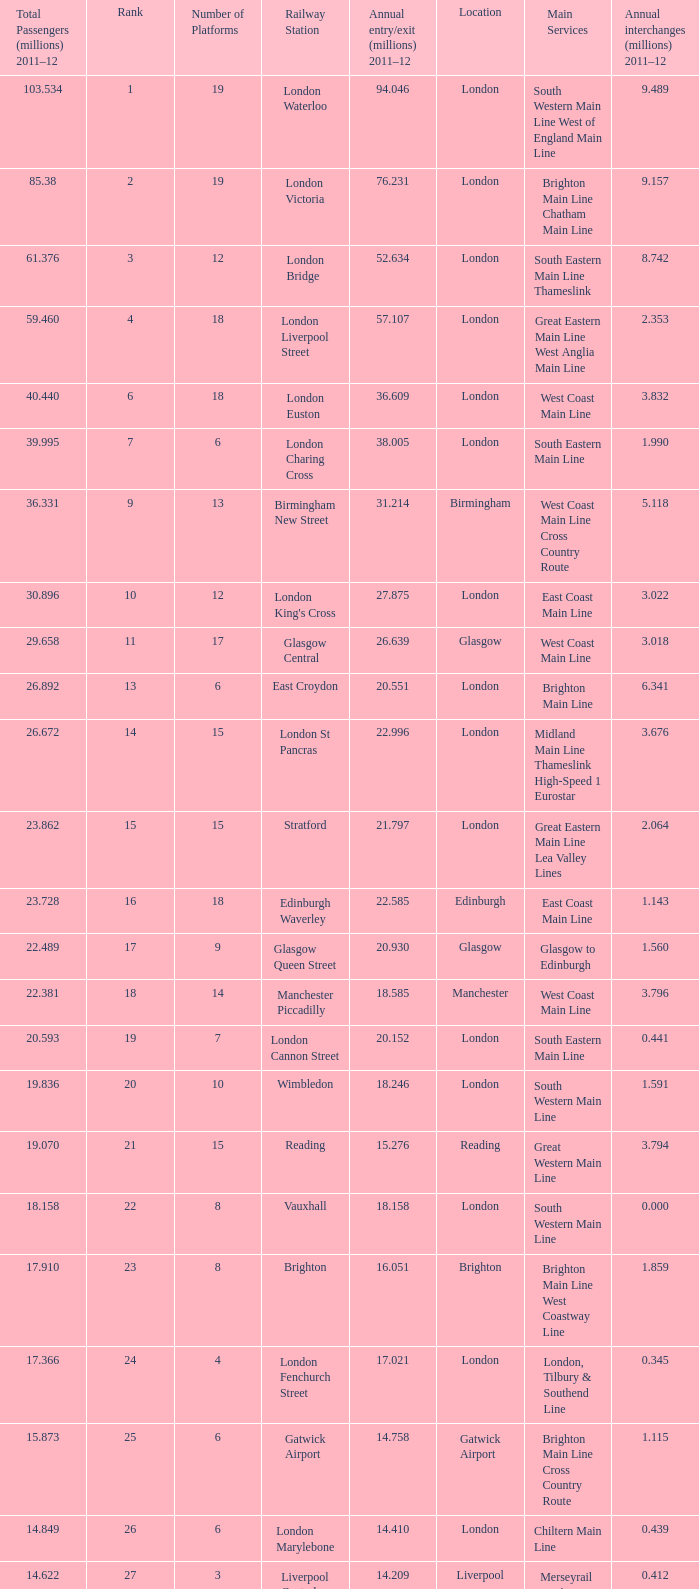What is the lowest rank of Gatwick Airport?  25.0. 